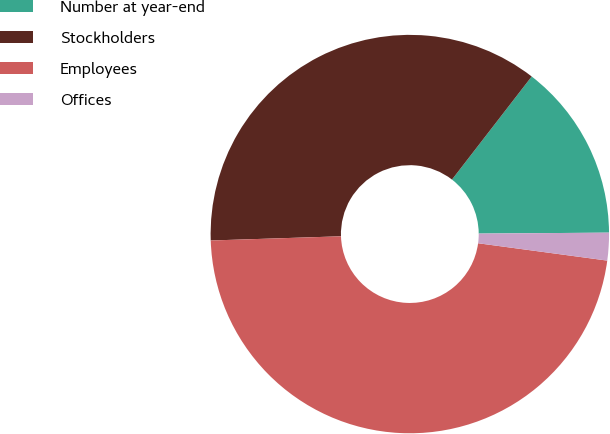Convert chart to OTSL. <chart><loc_0><loc_0><loc_500><loc_500><pie_chart><fcel>Number at year-end<fcel>Stockholders<fcel>Employees<fcel>Offices<nl><fcel>14.41%<fcel>35.99%<fcel>47.36%<fcel>2.24%<nl></chart> 